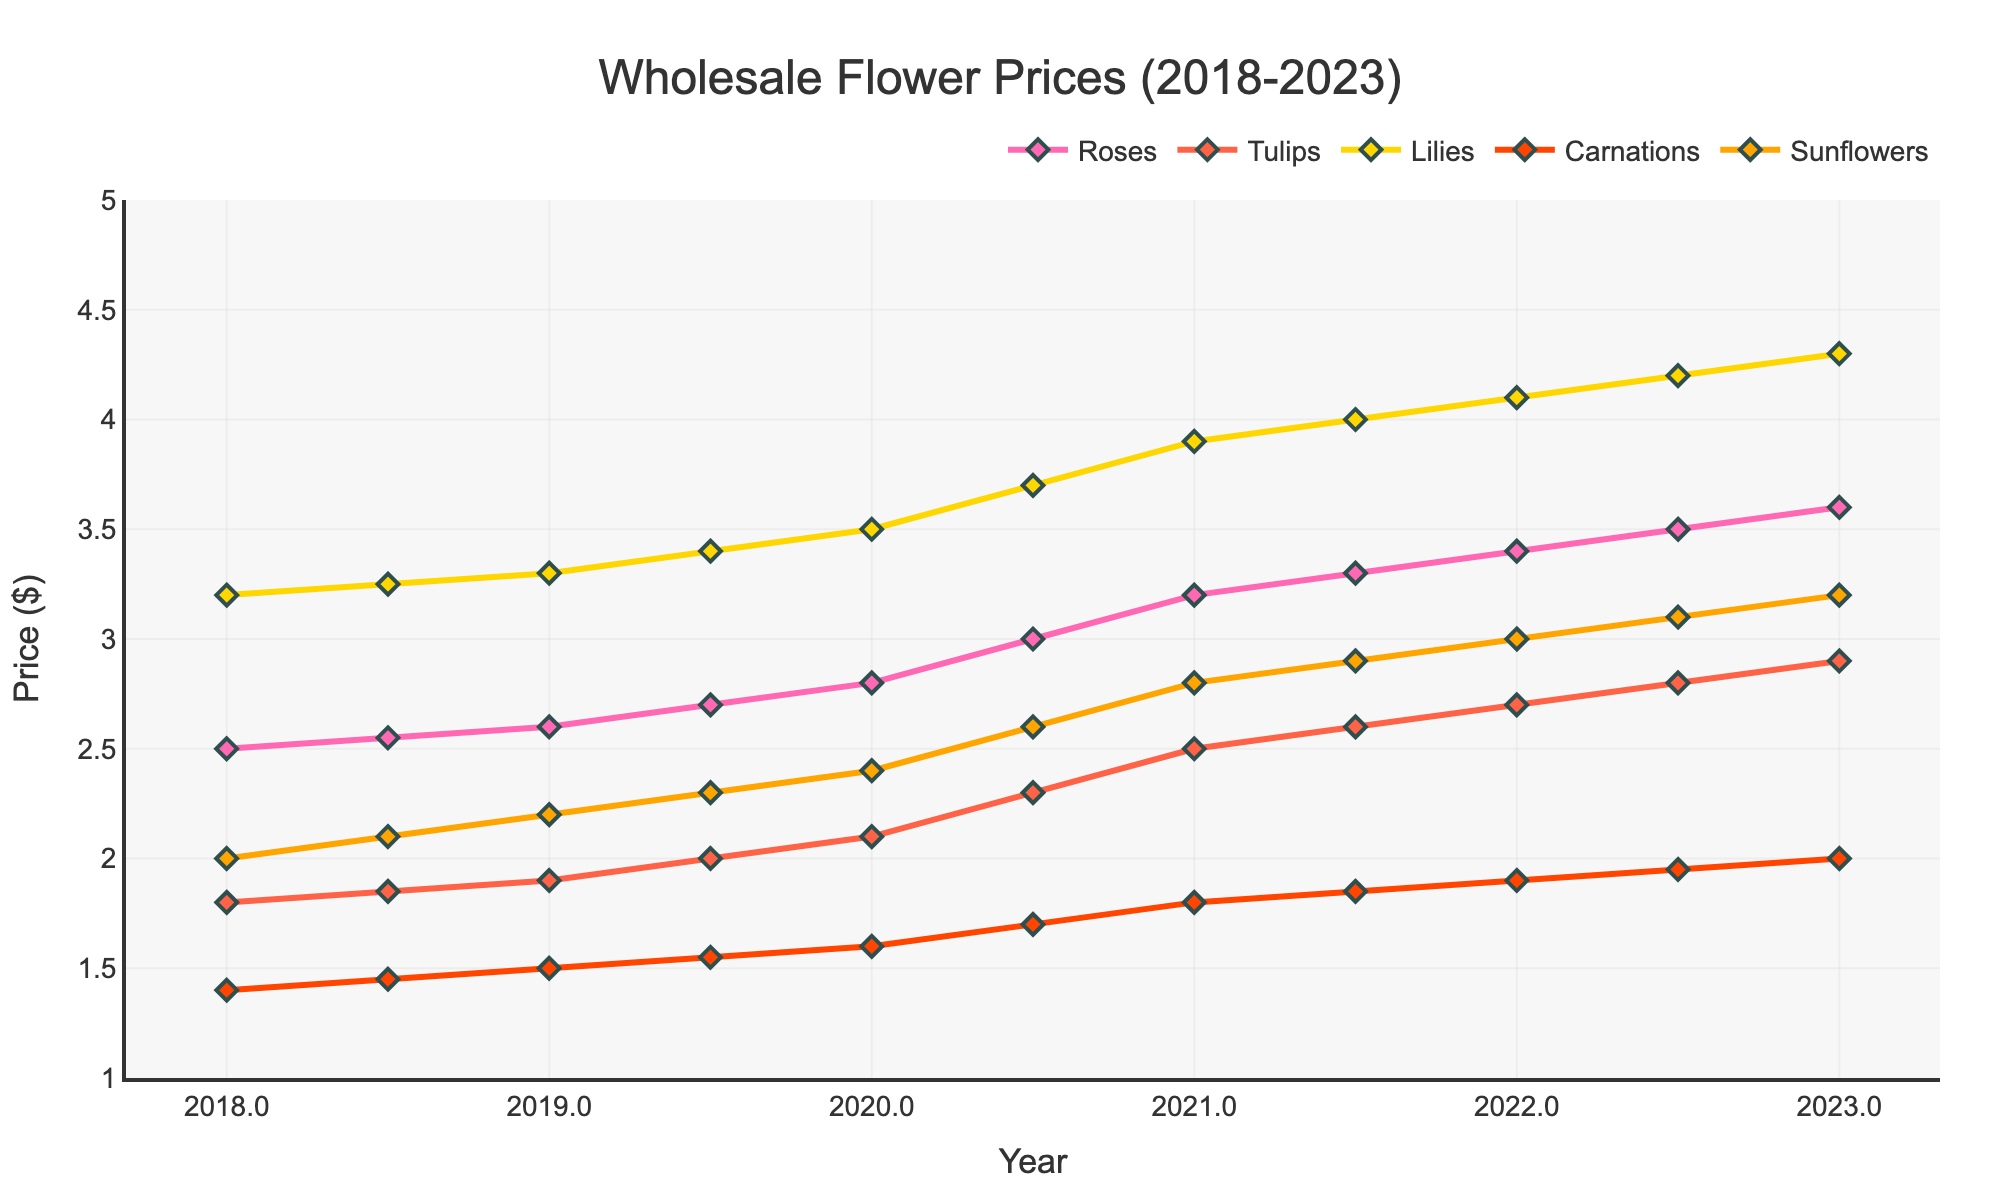What flower had the highest price increase from 2018 to 2023? First find the price of each flower in both 2018 and 2023. Then subtract the 2018 price from the 2023 price for each flower. The highest difference indicates the highest price increase.
Answer: Lilies Between which two consecutive years did Carnations experience the largest price increase? Calculate the price difference for Carnations between each consecutive year, starting from 2018 to 2023. The largest increase occurs between 2022.5 and 2023, as the price difference is 2.00 - 1.95 = 0.05 dollars.
Answer: 2022.5 and 2023 What was the average price of Sunflowers over the 5 years? Sum the prices of Sunflowers from 2018 to 2023 and divide by the number of years. The sum is 2.00 + 2.10 + 2.20 + 2.30 + 2.40 + 2.60 + 2.80 + 2.90 + 3.00 + 3.10 + 3.20 = 28.60. Dividing by 11 gives the average of 28.60 / 11 = 2.60.
Answer: 2.60 Which flower showed the most significant price fluctuation over these years? Compare the range of prices (maximum - minimum) for each flower from 2018 to 2023. The largest range indicates the most significant fluctuation. In this case, Lilies had the widest range (4.30 - 3.20 = 1.10).
Answer: Lilies In which year did Roses have the highest increase compared to the previous year's price? Compute the price difference of Roses year-over-year and identify the maximum difference. The largest increase occurred from 2020.5 to 2021 with an increase of 0.20 (3.20 - 3.00).
Answer: 2021 What is the price difference between the highest-priced and lowest-priced flower types in 2023? Identify the highest price and the lowest price among the flower types in 2023. The highest price is for Lilies (4.30) and the lowest is for Carnations (2.00). Subtract the lowest from the highest (4.30 - 2.00 = 2.30).
Answer: 2.30 How much did the price of Tulips increase from 2019.5 to 2022? Subtract the price of Tulips in 2019.5 (2.00) from the price in 2022 (2.70). The difference is 2.70 - 2.00 = 0.70.
Answer: 0.70 Between which two consecutive years did Sunflowers' prices have the steepest growth? Calculate the difference in Sunflower prices between each consecutive year, then determine the pair of years with the maximum increase. The steepest growth occurred between 2020 and 2020.5, with an increase of 0.20 (2.60 - 2.40).
Answer: 2020 and 2020.5 